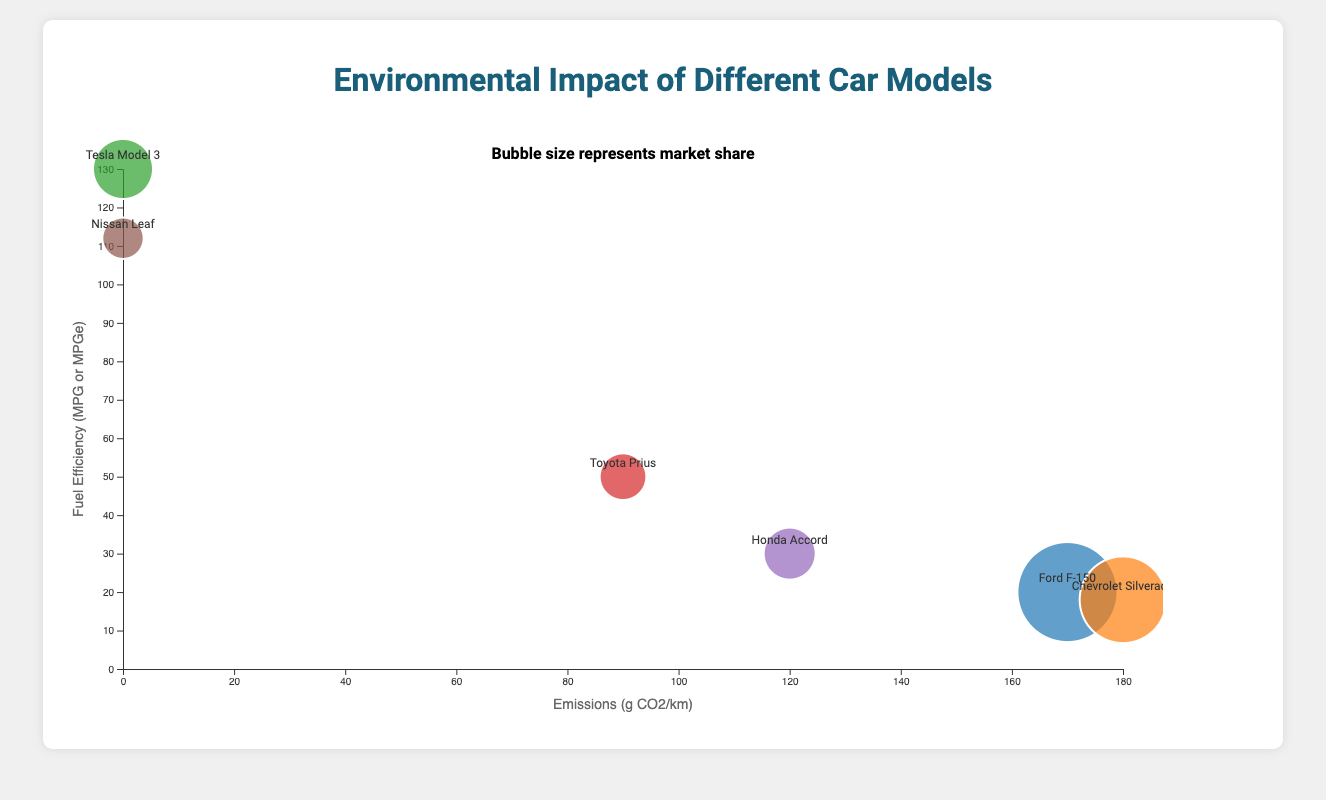What's the title of the chart? The title is usually prominently displayed at the top of the chart. Here, the title is "Environmental Impact of Different Car Models."
Answer: Environmental Impact of Different Car Models Which car model has zero emissions? The car models with zero emissions are the ones with an x-coordinate at 0 on the bubble chart. From the data, these are the "Tesla Model 3" and "Nissan Leaf."
Answer: Tesla Model 3 and Nissan Leaf How is market share visually represented in the bubble chart? Market share is represented by the size of the bubbles. Larger bubbles indicate larger market shares.
Answer: Bubble size What is the fuel efficiency of the Ford F-150? The fuel efficiency is represented by the y-axis. For the Ford F-150, the fuel efficiency value (y-coordinate) is 20.
Answer: 20 MPG Which car model has the highest fuel efficiency, and what is its value? The highest fuel efficiency corresponds to the highest point on the y-axis. The "Tesla Model 3" has the highest fuel efficiency at 130.
Answer: Tesla Model 3 with 130 MPG Arrange the car models in descending order of market share. By comparing the bubble sizes visually and referring to the data: Ford F-150 (30), Chevrolet Silverado (25), Tesla Model 3 (15), Honda Accord (12), Toyota Prius (10), Nissan Leaf (8).
Answer: Ford F-150, Chevrolet Silverado, Tesla Model 3, Honda Accord, Toyota Prius, Nissan Leaf What is the total market share of all the car models? Sum the market shares of all car models: 30 (Ford F-150) + 25 (Chevrolet Silverado) + 15 (Tesla Model 3) + 10 (Toyota Prius) + 12 (Honda Accord) + 8 (Nissan Leaf) = 100.
Answer: 100 Which car model has the highest emissions, and what is its market share? The highest emissions correspond to the furthest point on the x-axis. The "Chevrolet Silverado" has the highest emissions at 180 and a market share of 25.
Answer: Chevrolet Silverado with a 25 market share Compare the emissions and fuel efficiency of the Chevrolet Silverado and the Toyota Prius. Chevrolet Silverado: Emissions 180, Fuel Efficiency 18. Toyota Prius: Emissions 90, Fuel Efficiency 50. The Chevrolet Silverado has higher emissions and lower fuel efficiency compared to the Toyota Prius.
Answer: Chevrolet Silverado has higher emissions and lower fuel efficiency than Toyota Prius What does the text "Bubble size represents market share" indicate about how to interpret the bubbles in the chart? This text suggests that the area of each bubble is proportional to the market share of the respective car model. Larger bubbles indicate greater market share, and smaller bubbles indicate lesser market share.
Answer: Bubble area proportional to market share 